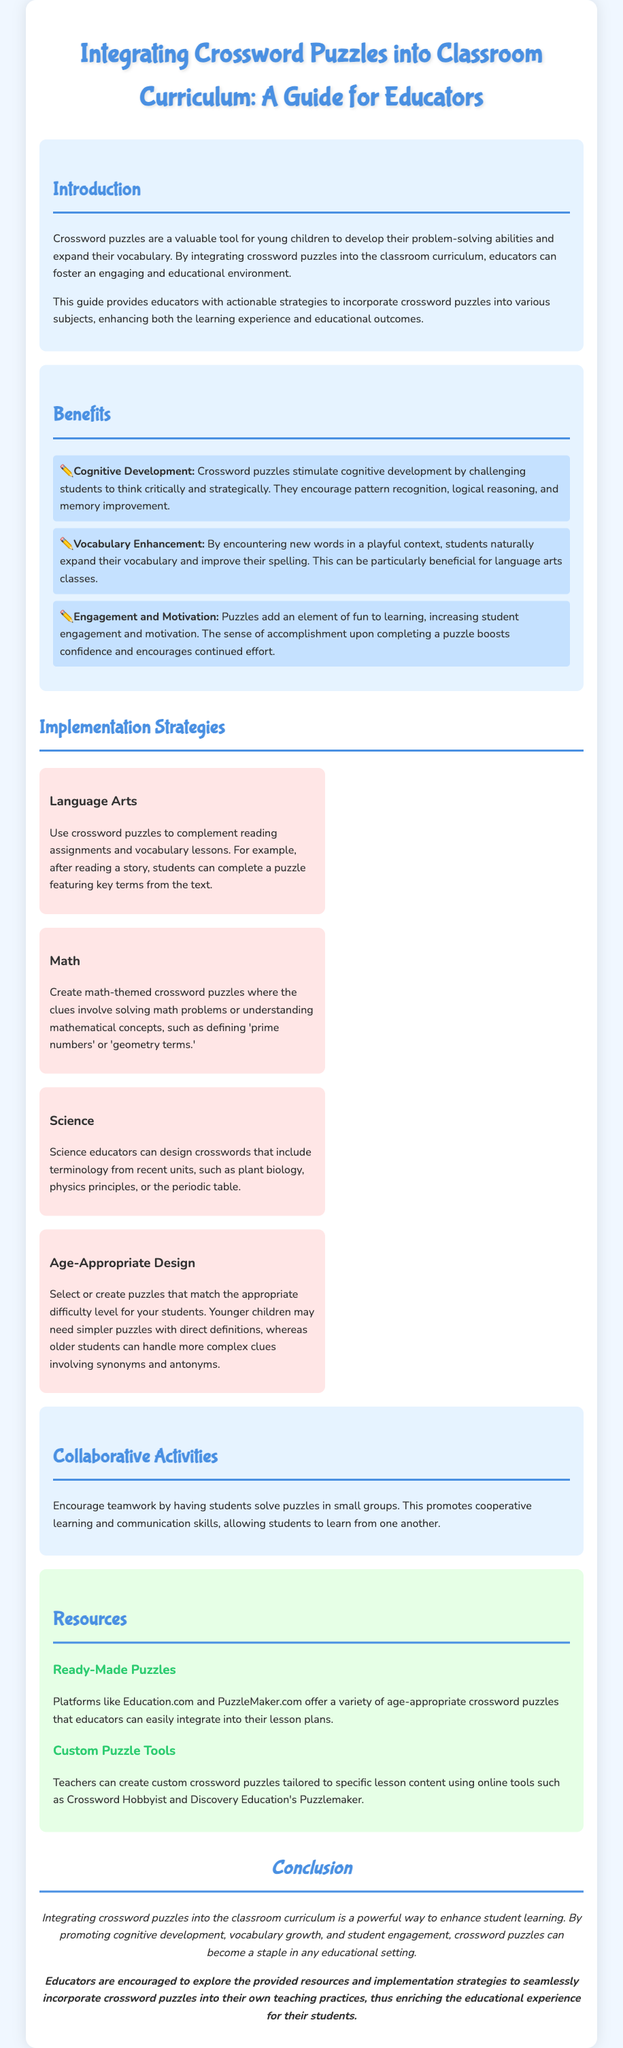What is the title of the document? The title is located at the top of the document and introduces the main topic.
Answer: Integrating Crossword Puzzles into Classroom Curriculum: A Guide for Educators What are crossword puzzles valuable for according to the document? The document mentions several benefits, particularly related to problem-solving and vocabulary.
Answer: Developing problem-solving abilities and expanding vocabulary How many benefits of crossword puzzles are listed in the document? The document provides a specific list of benefits related to the use of crossword puzzles in education.
Answer: Three Name one subject that can incorporate crossword puzzles according to the document. The document lists several subjects where crossword puzzles can be utilized, such as language arts or math.
Answer: Language arts Which online tool can teachers use to create custom crossword puzzles? The document provides examples of tools available for teachers to create puzzles tailored to their lesson content.
Answer: Crossword Hobbyist What is one advantage of using crossword puzzles in the classroom? The reasons listed in the document highlight the benefits of engagement and cognitive development.
Answer: Engagement and motivation What does the document suggest about puzzle difficulty? The document provides guidance on how to choose puzzles that match the age and skill levels of students.
Answer: Age-Appropriate Design What type of activities does the document suggest for enhancing learning? The section discusses collaborative efforts among students which contribute to effective learning.
Answer: Collaborative Activities 